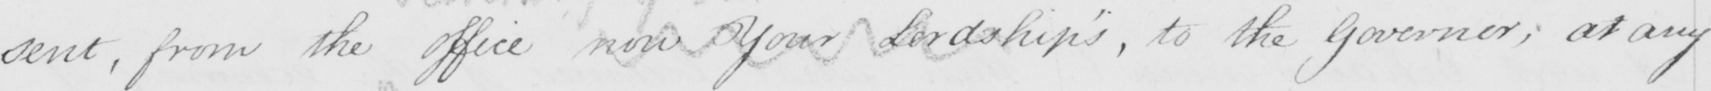What text is written in this handwritten line? sent , from the office now Your Lordship ' s , to the Governor ; at any 